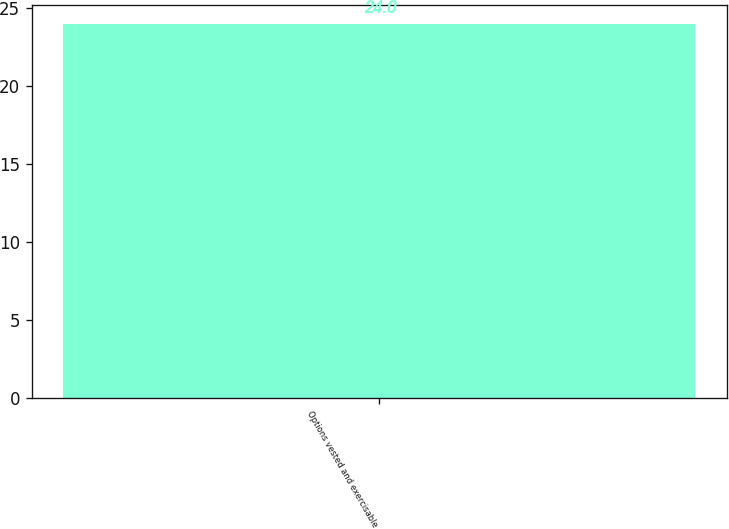Convert chart. <chart><loc_0><loc_0><loc_500><loc_500><bar_chart><fcel>Options vested and exercisable<nl><fcel>24<nl></chart> 